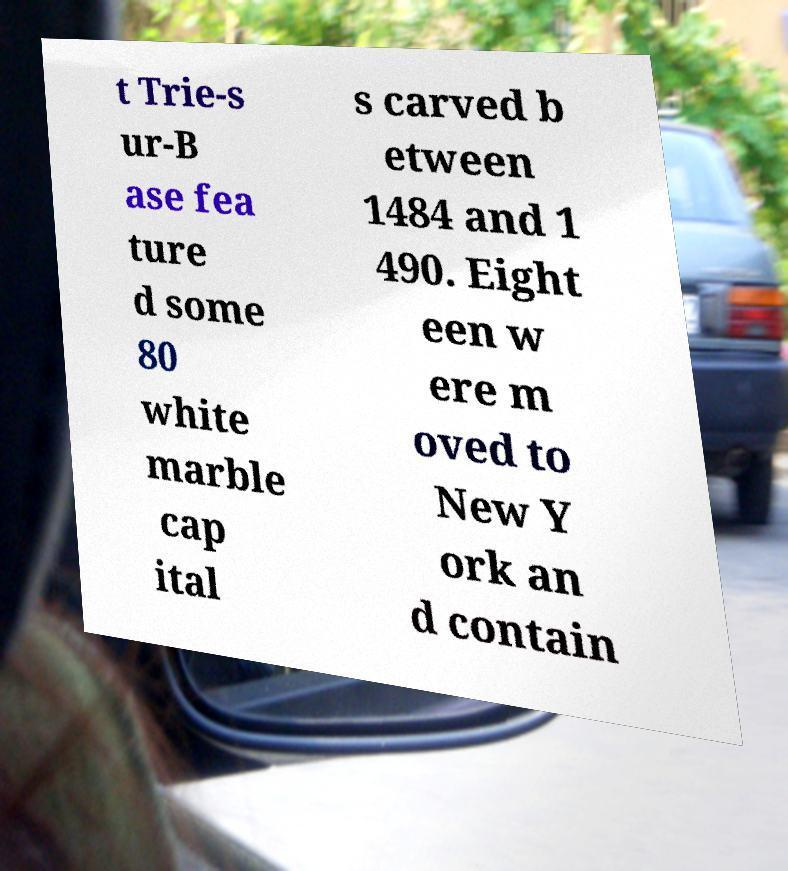Please identify and transcribe the text found in this image. t Trie-s ur-B ase fea ture d some 80 white marble cap ital s carved b etween 1484 and 1 490. Eight een w ere m oved to New Y ork an d contain 